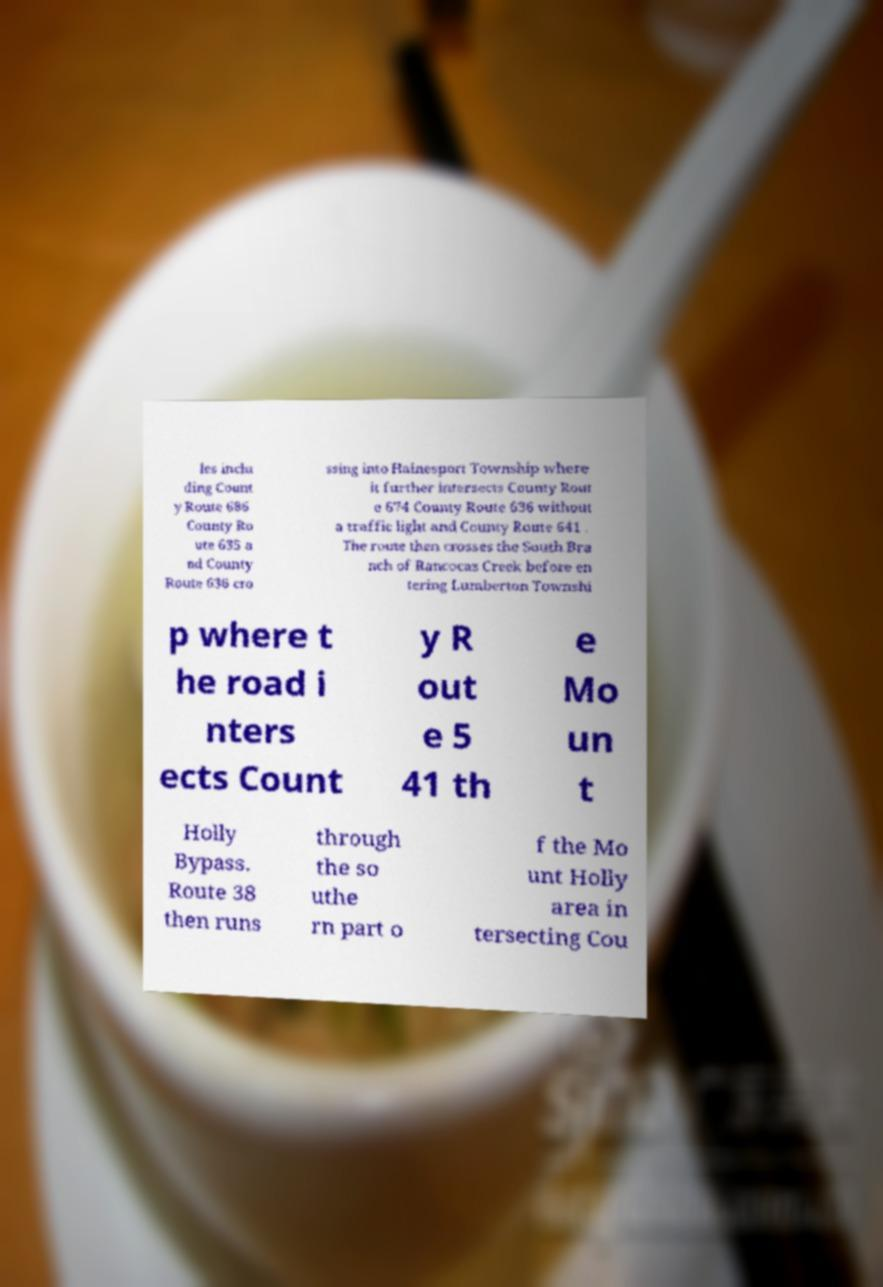Can you read and provide the text displayed in the image?This photo seems to have some interesting text. Can you extract and type it out for me? les inclu ding Count y Route 686 County Ro ute 635 a nd County Route 636 cro ssing into Hainesport Township where it further intersects County Rout e 674 County Route 636 without a traffic light and County Route 641 . The route then crosses the South Bra nch of Rancocas Creek before en tering Lumberton Townshi p where t he road i nters ects Count y R out e 5 41 th e Mo un t Holly Bypass. Route 38 then runs through the so uthe rn part o f the Mo unt Holly area in tersecting Cou 